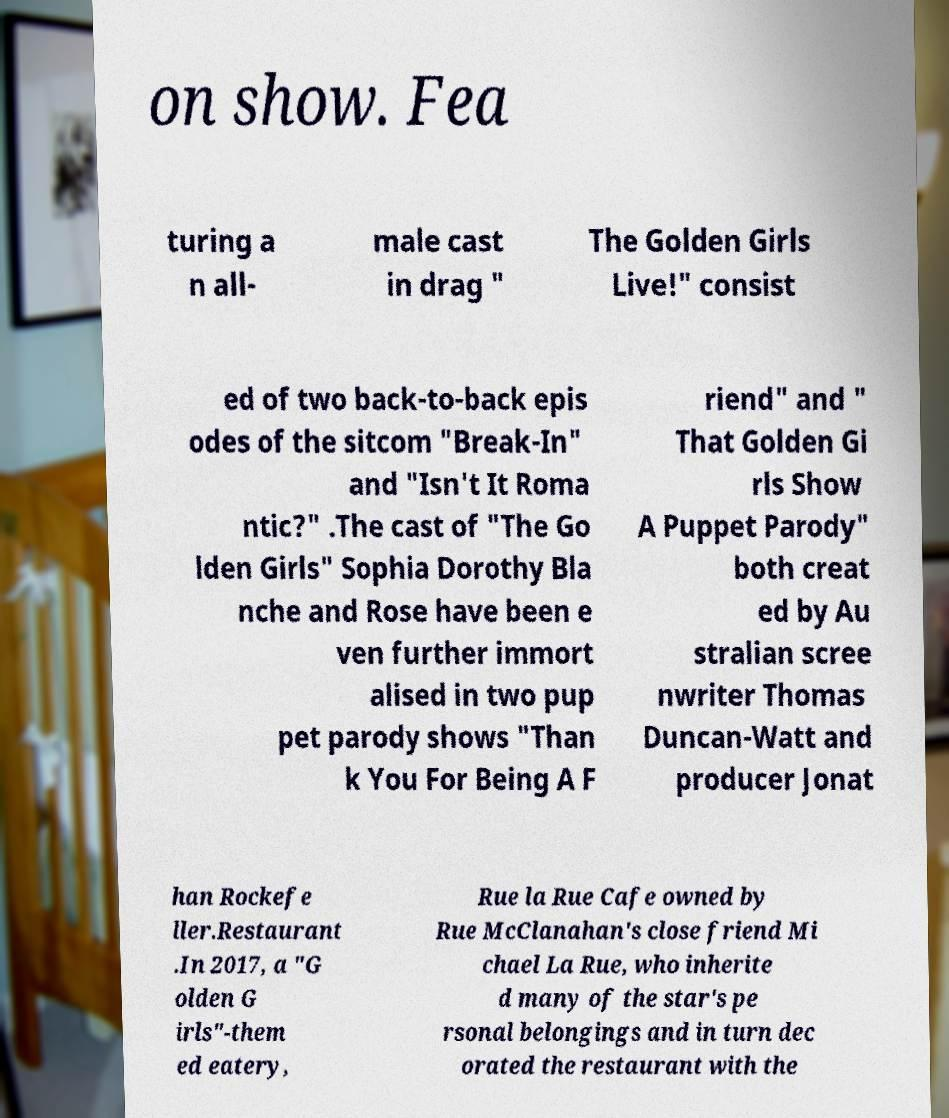For documentation purposes, I need the text within this image transcribed. Could you provide that? on show. Fea turing a n all- male cast in drag " The Golden Girls Live!" consist ed of two back-to-back epis odes of the sitcom "Break-In" and "Isn't It Roma ntic?" .The cast of "The Go lden Girls" Sophia Dorothy Bla nche and Rose have been e ven further immort alised in two pup pet parody shows "Than k You For Being A F riend" and " That Golden Gi rls Show A Puppet Parody" both creat ed by Au stralian scree nwriter Thomas Duncan-Watt and producer Jonat han Rockefe ller.Restaurant .In 2017, a "G olden G irls"-them ed eatery, Rue la Rue Cafe owned by Rue McClanahan's close friend Mi chael La Rue, who inherite d many of the star's pe rsonal belongings and in turn dec orated the restaurant with the 